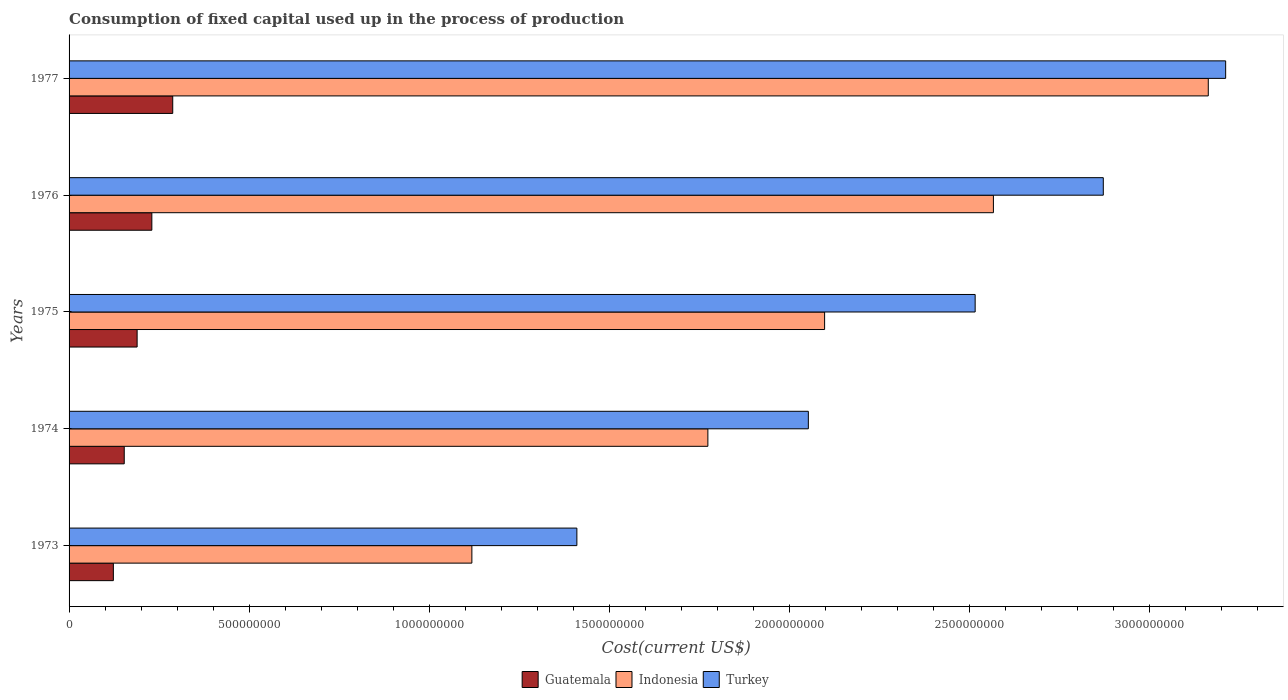How many different coloured bars are there?
Your answer should be very brief. 3. Are the number of bars per tick equal to the number of legend labels?
Ensure brevity in your answer.  Yes. What is the amount consumed in the process of production in Turkey in 1974?
Your answer should be very brief. 2.05e+09. Across all years, what is the maximum amount consumed in the process of production in Guatemala?
Offer a very short reply. 2.88e+08. Across all years, what is the minimum amount consumed in the process of production in Indonesia?
Make the answer very short. 1.12e+09. In which year was the amount consumed in the process of production in Guatemala maximum?
Your answer should be compact. 1977. What is the total amount consumed in the process of production in Guatemala in the graph?
Provide a short and direct response. 9.83e+08. What is the difference between the amount consumed in the process of production in Turkey in 1975 and that in 1977?
Your answer should be very brief. -6.96e+08. What is the difference between the amount consumed in the process of production in Guatemala in 1973 and the amount consumed in the process of production in Turkey in 1976?
Offer a terse response. -2.75e+09. What is the average amount consumed in the process of production in Indonesia per year?
Your answer should be compact. 2.14e+09. In the year 1975, what is the difference between the amount consumed in the process of production in Turkey and amount consumed in the process of production in Guatemala?
Provide a short and direct response. 2.33e+09. What is the ratio of the amount consumed in the process of production in Guatemala in 1973 to that in 1974?
Provide a succinct answer. 0.8. Is the difference between the amount consumed in the process of production in Turkey in 1975 and 1977 greater than the difference between the amount consumed in the process of production in Guatemala in 1975 and 1977?
Make the answer very short. No. What is the difference between the highest and the second highest amount consumed in the process of production in Indonesia?
Make the answer very short. 5.97e+08. What is the difference between the highest and the lowest amount consumed in the process of production in Indonesia?
Your answer should be very brief. 2.05e+09. In how many years, is the amount consumed in the process of production in Guatemala greater than the average amount consumed in the process of production in Guatemala taken over all years?
Provide a short and direct response. 2. What does the 2nd bar from the top in 1976 represents?
Your response must be concise. Indonesia. What does the 1st bar from the bottom in 1974 represents?
Keep it short and to the point. Guatemala. How many bars are there?
Your response must be concise. 15. Are all the bars in the graph horizontal?
Your response must be concise. Yes. What is the difference between two consecutive major ticks on the X-axis?
Your answer should be very brief. 5.00e+08. Are the values on the major ticks of X-axis written in scientific E-notation?
Offer a terse response. No. How many legend labels are there?
Make the answer very short. 3. What is the title of the graph?
Ensure brevity in your answer.  Consumption of fixed capital used up in the process of production. Does "Marshall Islands" appear as one of the legend labels in the graph?
Ensure brevity in your answer.  No. What is the label or title of the X-axis?
Your answer should be compact. Cost(current US$). What is the label or title of the Y-axis?
Offer a very short reply. Years. What is the Cost(current US$) in Guatemala in 1973?
Keep it short and to the point. 1.23e+08. What is the Cost(current US$) in Indonesia in 1973?
Offer a terse response. 1.12e+09. What is the Cost(current US$) of Turkey in 1973?
Your response must be concise. 1.41e+09. What is the Cost(current US$) of Guatemala in 1974?
Your response must be concise. 1.53e+08. What is the Cost(current US$) in Indonesia in 1974?
Give a very brief answer. 1.77e+09. What is the Cost(current US$) of Turkey in 1974?
Keep it short and to the point. 2.05e+09. What is the Cost(current US$) in Guatemala in 1975?
Offer a very short reply. 1.89e+08. What is the Cost(current US$) in Indonesia in 1975?
Offer a terse response. 2.10e+09. What is the Cost(current US$) of Turkey in 1975?
Offer a very short reply. 2.52e+09. What is the Cost(current US$) of Guatemala in 1976?
Provide a succinct answer. 2.30e+08. What is the Cost(current US$) in Indonesia in 1976?
Your answer should be very brief. 2.57e+09. What is the Cost(current US$) of Turkey in 1976?
Your response must be concise. 2.87e+09. What is the Cost(current US$) of Guatemala in 1977?
Ensure brevity in your answer.  2.88e+08. What is the Cost(current US$) of Indonesia in 1977?
Give a very brief answer. 3.16e+09. What is the Cost(current US$) of Turkey in 1977?
Give a very brief answer. 3.21e+09. Across all years, what is the maximum Cost(current US$) in Guatemala?
Give a very brief answer. 2.88e+08. Across all years, what is the maximum Cost(current US$) of Indonesia?
Offer a very short reply. 3.16e+09. Across all years, what is the maximum Cost(current US$) in Turkey?
Keep it short and to the point. 3.21e+09. Across all years, what is the minimum Cost(current US$) of Guatemala?
Give a very brief answer. 1.23e+08. Across all years, what is the minimum Cost(current US$) of Indonesia?
Keep it short and to the point. 1.12e+09. Across all years, what is the minimum Cost(current US$) in Turkey?
Keep it short and to the point. 1.41e+09. What is the total Cost(current US$) in Guatemala in the graph?
Your response must be concise. 9.83e+08. What is the total Cost(current US$) of Indonesia in the graph?
Offer a very short reply. 1.07e+1. What is the total Cost(current US$) of Turkey in the graph?
Make the answer very short. 1.21e+1. What is the difference between the Cost(current US$) in Guatemala in 1973 and that in 1974?
Ensure brevity in your answer.  -3.02e+07. What is the difference between the Cost(current US$) in Indonesia in 1973 and that in 1974?
Provide a succinct answer. -6.56e+08. What is the difference between the Cost(current US$) of Turkey in 1973 and that in 1974?
Your answer should be compact. -6.43e+08. What is the difference between the Cost(current US$) of Guatemala in 1973 and that in 1975?
Provide a short and direct response. -6.60e+07. What is the difference between the Cost(current US$) of Indonesia in 1973 and that in 1975?
Your answer should be very brief. -9.80e+08. What is the difference between the Cost(current US$) in Turkey in 1973 and that in 1975?
Give a very brief answer. -1.11e+09. What is the difference between the Cost(current US$) of Guatemala in 1973 and that in 1976?
Give a very brief answer. -1.07e+08. What is the difference between the Cost(current US$) of Indonesia in 1973 and that in 1976?
Offer a terse response. -1.45e+09. What is the difference between the Cost(current US$) in Turkey in 1973 and that in 1976?
Provide a short and direct response. -1.46e+09. What is the difference between the Cost(current US$) of Guatemala in 1973 and that in 1977?
Give a very brief answer. -1.65e+08. What is the difference between the Cost(current US$) of Indonesia in 1973 and that in 1977?
Ensure brevity in your answer.  -2.05e+09. What is the difference between the Cost(current US$) of Turkey in 1973 and that in 1977?
Your answer should be very brief. -1.80e+09. What is the difference between the Cost(current US$) in Guatemala in 1974 and that in 1975?
Your response must be concise. -3.58e+07. What is the difference between the Cost(current US$) in Indonesia in 1974 and that in 1975?
Provide a succinct answer. -3.24e+08. What is the difference between the Cost(current US$) of Turkey in 1974 and that in 1975?
Offer a terse response. -4.63e+08. What is the difference between the Cost(current US$) of Guatemala in 1974 and that in 1976?
Ensure brevity in your answer.  -7.67e+07. What is the difference between the Cost(current US$) in Indonesia in 1974 and that in 1976?
Provide a short and direct response. -7.93e+08. What is the difference between the Cost(current US$) in Turkey in 1974 and that in 1976?
Offer a very short reply. -8.19e+08. What is the difference between the Cost(current US$) in Guatemala in 1974 and that in 1977?
Offer a terse response. -1.35e+08. What is the difference between the Cost(current US$) in Indonesia in 1974 and that in 1977?
Provide a short and direct response. -1.39e+09. What is the difference between the Cost(current US$) in Turkey in 1974 and that in 1977?
Give a very brief answer. -1.16e+09. What is the difference between the Cost(current US$) of Guatemala in 1975 and that in 1976?
Provide a succinct answer. -4.09e+07. What is the difference between the Cost(current US$) in Indonesia in 1975 and that in 1976?
Give a very brief answer. -4.69e+08. What is the difference between the Cost(current US$) of Turkey in 1975 and that in 1976?
Keep it short and to the point. -3.56e+08. What is the difference between the Cost(current US$) in Guatemala in 1975 and that in 1977?
Keep it short and to the point. -9.89e+07. What is the difference between the Cost(current US$) of Indonesia in 1975 and that in 1977?
Make the answer very short. -1.07e+09. What is the difference between the Cost(current US$) of Turkey in 1975 and that in 1977?
Make the answer very short. -6.96e+08. What is the difference between the Cost(current US$) in Guatemala in 1976 and that in 1977?
Provide a short and direct response. -5.81e+07. What is the difference between the Cost(current US$) in Indonesia in 1976 and that in 1977?
Offer a terse response. -5.97e+08. What is the difference between the Cost(current US$) in Turkey in 1976 and that in 1977?
Provide a short and direct response. -3.40e+08. What is the difference between the Cost(current US$) in Guatemala in 1973 and the Cost(current US$) in Indonesia in 1974?
Your answer should be compact. -1.65e+09. What is the difference between the Cost(current US$) of Guatemala in 1973 and the Cost(current US$) of Turkey in 1974?
Keep it short and to the point. -1.93e+09. What is the difference between the Cost(current US$) in Indonesia in 1973 and the Cost(current US$) in Turkey in 1974?
Provide a succinct answer. -9.35e+08. What is the difference between the Cost(current US$) in Guatemala in 1973 and the Cost(current US$) in Indonesia in 1975?
Provide a short and direct response. -1.98e+09. What is the difference between the Cost(current US$) in Guatemala in 1973 and the Cost(current US$) in Turkey in 1975?
Offer a terse response. -2.39e+09. What is the difference between the Cost(current US$) in Indonesia in 1973 and the Cost(current US$) in Turkey in 1975?
Provide a succinct answer. -1.40e+09. What is the difference between the Cost(current US$) of Guatemala in 1973 and the Cost(current US$) of Indonesia in 1976?
Ensure brevity in your answer.  -2.44e+09. What is the difference between the Cost(current US$) of Guatemala in 1973 and the Cost(current US$) of Turkey in 1976?
Offer a very short reply. -2.75e+09. What is the difference between the Cost(current US$) of Indonesia in 1973 and the Cost(current US$) of Turkey in 1976?
Offer a very short reply. -1.75e+09. What is the difference between the Cost(current US$) of Guatemala in 1973 and the Cost(current US$) of Indonesia in 1977?
Your answer should be compact. -3.04e+09. What is the difference between the Cost(current US$) of Guatemala in 1973 and the Cost(current US$) of Turkey in 1977?
Keep it short and to the point. -3.09e+09. What is the difference between the Cost(current US$) in Indonesia in 1973 and the Cost(current US$) in Turkey in 1977?
Your answer should be very brief. -2.09e+09. What is the difference between the Cost(current US$) of Guatemala in 1974 and the Cost(current US$) of Indonesia in 1975?
Provide a succinct answer. -1.95e+09. What is the difference between the Cost(current US$) in Guatemala in 1974 and the Cost(current US$) in Turkey in 1975?
Your answer should be compact. -2.36e+09. What is the difference between the Cost(current US$) of Indonesia in 1974 and the Cost(current US$) of Turkey in 1975?
Your answer should be compact. -7.42e+08. What is the difference between the Cost(current US$) in Guatemala in 1974 and the Cost(current US$) in Indonesia in 1976?
Your response must be concise. -2.41e+09. What is the difference between the Cost(current US$) in Guatemala in 1974 and the Cost(current US$) in Turkey in 1976?
Make the answer very short. -2.72e+09. What is the difference between the Cost(current US$) of Indonesia in 1974 and the Cost(current US$) of Turkey in 1976?
Your answer should be very brief. -1.10e+09. What is the difference between the Cost(current US$) of Guatemala in 1974 and the Cost(current US$) of Indonesia in 1977?
Provide a short and direct response. -3.01e+09. What is the difference between the Cost(current US$) of Guatemala in 1974 and the Cost(current US$) of Turkey in 1977?
Offer a very short reply. -3.06e+09. What is the difference between the Cost(current US$) of Indonesia in 1974 and the Cost(current US$) of Turkey in 1977?
Make the answer very short. -1.44e+09. What is the difference between the Cost(current US$) in Guatemala in 1975 and the Cost(current US$) in Indonesia in 1976?
Provide a succinct answer. -2.38e+09. What is the difference between the Cost(current US$) in Guatemala in 1975 and the Cost(current US$) in Turkey in 1976?
Ensure brevity in your answer.  -2.68e+09. What is the difference between the Cost(current US$) in Indonesia in 1975 and the Cost(current US$) in Turkey in 1976?
Provide a short and direct response. -7.74e+08. What is the difference between the Cost(current US$) of Guatemala in 1975 and the Cost(current US$) of Indonesia in 1977?
Offer a very short reply. -2.98e+09. What is the difference between the Cost(current US$) in Guatemala in 1975 and the Cost(current US$) in Turkey in 1977?
Offer a terse response. -3.02e+09. What is the difference between the Cost(current US$) of Indonesia in 1975 and the Cost(current US$) of Turkey in 1977?
Offer a very short reply. -1.11e+09. What is the difference between the Cost(current US$) of Guatemala in 1976 and the Cost(current US$) of Indonesia in 1977?
Make the answer very short. -2.93e+09. What is the difference between the Cost(current US$) of Guatemala in 1976 and the Cost(current US$) of Turkey in 1977?
Give a very brief answer. -2.98e+09. What is the difference between the Cost(current US$) of Indonesia in 1976 and the Cost(current US$) of Turkey in 1977?
Provide a succinct answer. -6.45e+08. What is the average Cost(current US$) of Guatemala per year?
Give a very brief answer. 1.97e+08. What is the average Cost(current US$) of Indonesia per year?
Give a very brief answer. 2.14e+09. What is the average Cost(current US$) in Turkey per year?
Ensure brevity in your answer.  2.41e+09. In the year 1973, what is the difference between the Cost(current US$) in Guatemala and Cost(current US$) in Indonesia?
Keep it short and to the point. -9.96e+08. In the year 1973, what is the difference between the Cost(current US$) of Guatemala and Cost(current US$) of Turkey?
Your answer should be very brief. -1.29e+09. In the year 1973, what is the difference between the Cost(current US$) in Indonesia and Cost(current US$) in Turkey?
Your answer should be compact. -2.92e+08. In the year 1974, what is the difference between the Cost(current US$) of Guatemala and Cost(current US$) of Indonesia?
Provide a short and direct response. -1.62e+09. In the year 1974, what is the difference between the Cost(current US$) in Guatemala and Cost(current US$) in Turkey?
Provide a short and direct response. -1.90e+09. In the year 1974, what is the difference between the Cost(current US$) of Indonesia and Cost(current US$) of Turkey?
Your response must be concise. -2.79e+08. In the year 1975, what is the difference between the Cost(current US$) of Guatemala and Cost(current US$) of Indonesia?
Offer a terse response. -1.91e+09. In the year 1975, what is the difference between the Cost(current US$) in Guatemala and Cost(current US$) in Turkey?
Ensure brevity in your answer.  -2.33e+09. In the year 1975, what is the difference between the Cost(current US$) in Indonesia and Cost(current US$) in Turkey?
Your answer should be compact. -4.18e+08. In the year 1976, what is the difference between the Cost(current US$) of Guatemala and Cost(current US$) of Indonesia?
Give a very brief answer. -2.34e+09. In the year 1976, what is the difference between the Cost(current US$) of Guatemala and Cost(current US$) of Turkey?
Offer a very short reply. -2.64e+09. In the year 1976, what is the difference between the Cost(current US$) in Indonesia and Cost(current US$) in Turkey?
Provide a short and direct response. -3.05e+08. In the year 1977, what is the difference between the Cost(current US$) of Guatemala and Cost(current US$) of Indonesia?
Keep it short and to the point. -2.88e+09. In the year 1977, what is the difference between the Cost(current US$) of Guatemala and Cost(current US$) of Turkey?
Provide a succinct answer. -2.92e+09. In the year 1977, what is the difference between the Cost(current US$) in Indonesia and Cost(current US$) in Turkey?
Provide a short and direct response. -4.83e+07. What is the ratio of the Cost(current US$) in Guatemala in 1973 to that in 1974?
Offer a very short reply. 0.8. What is the ratio of the Cost(current US$) of Indonesia in 1973 to that in 1974?
Provide a succinct answer. 0.63. What is the ratio of the Cost(current US$) in Turkey in 1973 to that in 1974?
Ensure brevity in your answer.  0.69. What is the ratio of the Cost(current US$) of Guatemala in 1973 to that in 1975?
Offer a very short reply. 0.65. What is the ratio of the Cost(current US$) of Indonesia in 1973 to that in 1975?
Your answer should be very brief. 0.53. What is the ratio of the Cost(current US$) in Turkey in 1973 to that in 1975?
Offer a very short reply. 0.56. What is the ratio of the Cost(current US$) of Guatemala in 1973 to that in 1976?
Your response must be concise. 0.54. What is the ratio of the Cost(current US$) in Indonesia in 1973 to that in 1976?
Ensure brevity in your answer.  0.44. What is the ratio of the Cost(current US$) in Turkey in 1973 to that in 1976?
Offer a very short reply. 0.49. What is the ratio of the Cost(current US$) in Guatemala in 1973 to that in 1977?
Offer a terse response. 0.43. What is the ratio of the Cost(current US$) in Indonesia in 1973 to that in 1977?
Your answer should be very brief. 0.35. What is the ratio of the Cost(current US$) of Turkey in 1973 to that in 1977?
Give a very brief answer. 0.44. What is the ratio of the Cost(current US$) of Guatemala in 1974 to that in 1975?
Provide a short and direct response. 0.81. What is the ratio of the Cost(current US$) in Indonesia in 1974 to that in 1975?
Your response must be concise. 0.85. What is the ratio of the Cost(current US$) in Turkey in 1974 to that in 1975?
Ensure brevity in your answer.  0.82. What is the ratio of the Cost(current US$) in Guatemala in 1974 to that in 1976?
Your answer should be compact. 0.67. What is the ratio of the Cost(current US$) in Indonesia in 1974 to that in 1976?
Ensure brevity in your answer.  0.69. What is the ratio of the Cost(current US$) in Turkey in 1974 to that in 1976?
Make the answer very short. 0.71. What is the ratio of the Cost(current US$) in Guatemala in 1974 to that in 1977?
Keep it short and to the point. 0.53. What is the ratio of the Cost(current US$) of Indonesia in 1974 to that in 1977?
Ensure brevity in your answer.  0.56. What is the ratio of the Cost(current US$) of Turkey in 1974 to that in 1977?
Give a very brief answer. 0.64. What is the ratio of the Cost(current US$) in Guatemala in 1975 to that in 1976?
Make the answer very short. 0.82. What is the ratio of the Cost(current US$) in Indonesia in 1975 to that in 1976?
Give a very brief answer. 0.82. What is the ratio of the Cost(current US$) of Turkey in 1975 to that in 1976?
Your answer should be compact. 0.88. What is the ratio of the Cost(current US$) in Guatemala in 1975 to that in 1977?
Give a very brief answer. 0.66. What is the ratio of the Cost(current US$) of Indonesia in 1975 to that in 1977?
Offer a terse response. 0.66. What is the ratio of the Cost(current US$) of Turkey in 1975 to that in 1977?
Give a very brief answer. 0.78. What is the ratio of the Cost(current US$) in Guatemala in 1976 to that in 1977?
Give a very brief answer. 0.8. What is the ratio of the Cost(current US$) in Indonesia in 1976 to that in 1977?
Make the answer very short. 0.81. What is the ratio of the Cost(current US$) of Turkey in 1976 to that in 1977?
Your answer should be compact. 0.89. What is the difference between the highest and the second highest Cost(current US$) of Guatemala?
Provide a succinct answer. 5.81e+07. What is the difference between the highest and the second highest Cost(current US$) of Indonesia?
Your response must be concise. 5.97e+08. What is the difference between the highest and the second highest Cost(current US$) in Turkey?
Give a very brief answer. 3.40e+08. What is the difference between the highest and the lowest Cost(current US$) of Guatemala?
Provide a short and direct response. 1.65e+08. What is the difference between the highest and the lowest Cost(current US$) in Indonesia?
Provide a short and direct response. 2.05e+09. What is the difference between the highest and the lowest Cost(current US$) of Turkey?
Provide a short and direct response. 1.80e+09. 